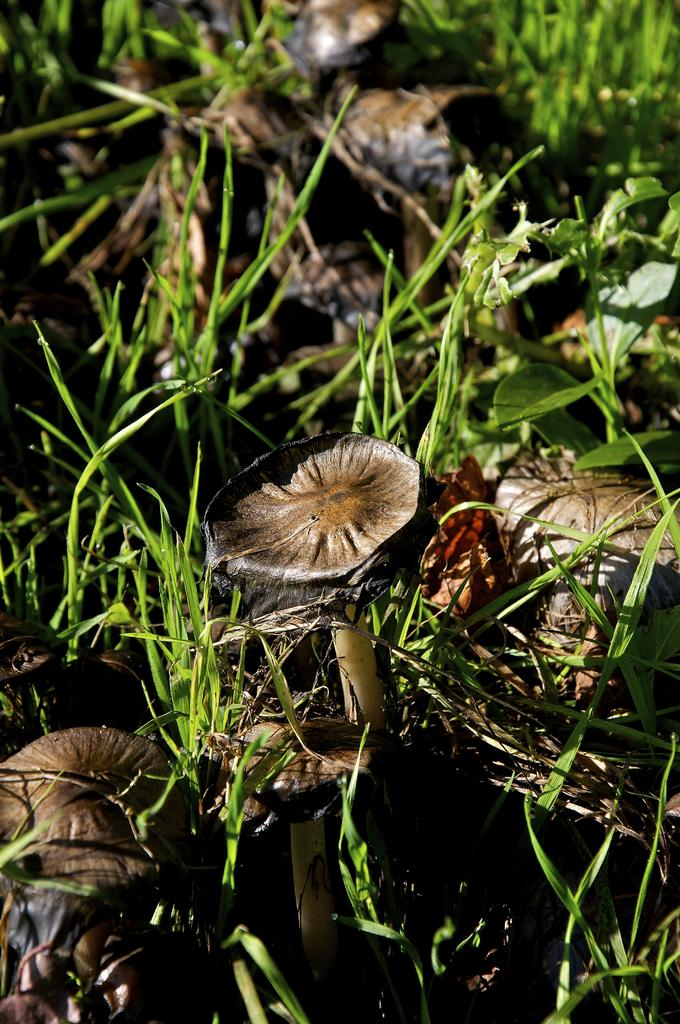What type of vegetation can be seen in the image? There are mushrooms and grass in the image. What other plant is visible in the image? There is a plant in the image. How many flowers are present in the image? There are no flowers visible in the image; it features include mushrooms, grass, and a plant. 